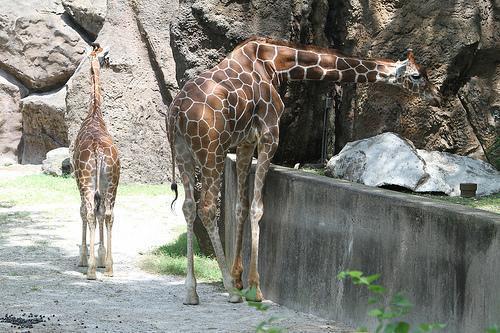How many giraffes?
Give a very brief answer. 2. 